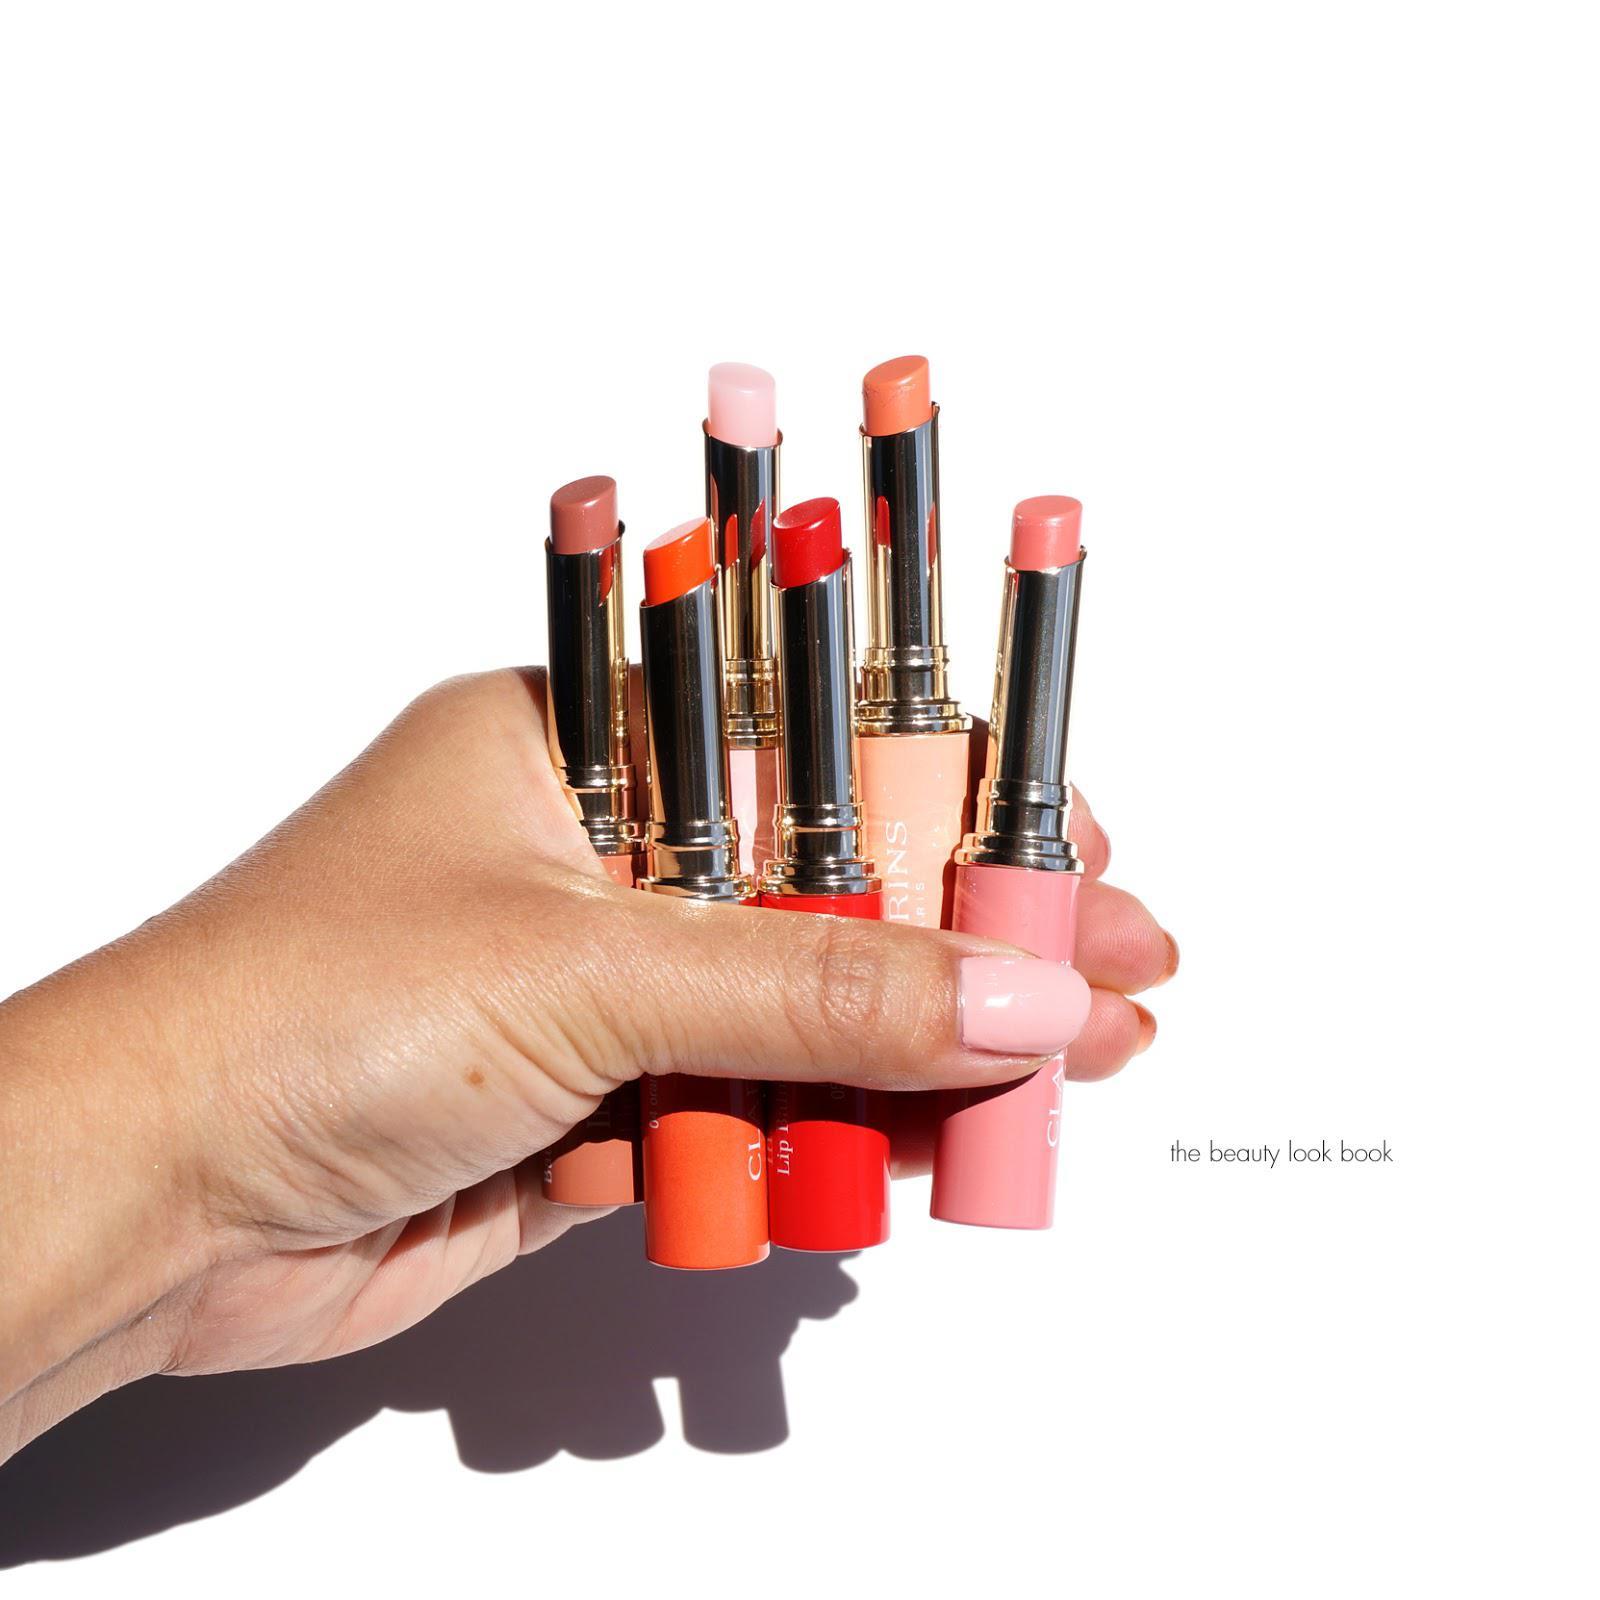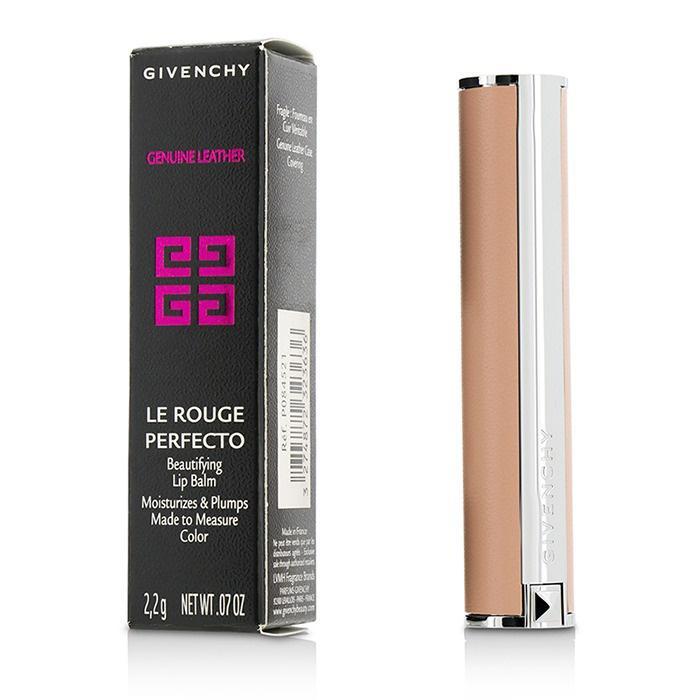The first image is the image on the left, the second image is the image on the right. For the images shown, is this caption "Someone is holding some lip stick." true? Answer yes or no. Yes. The first image is the image on the left, the second image is the image on the right. Assess this claim about the two images: "Many shades of reddish lipstick are shown with the caps off in at least one of the pictures.". Correct or not? Answer yes or no. Yes. 